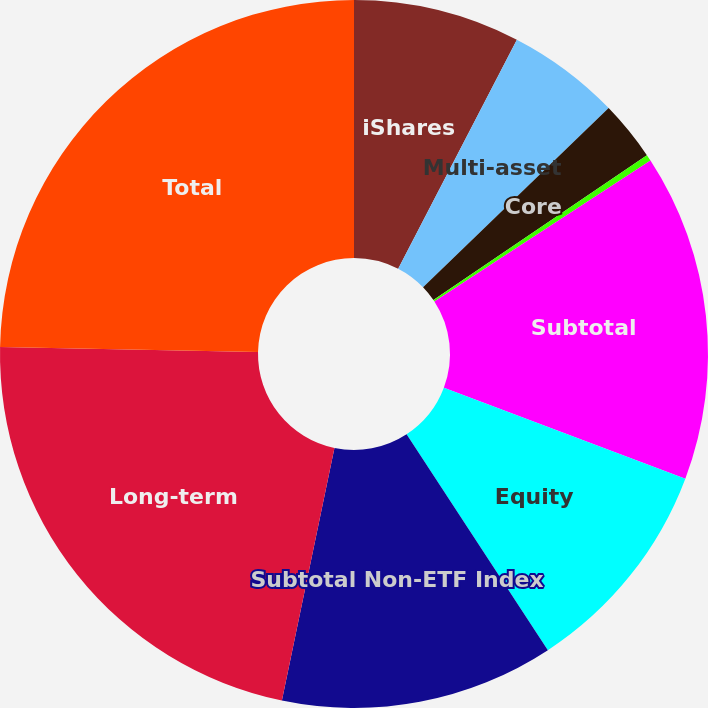Convert chart to OTSL. <chart><loc_0><loc_0><loc_500><loc_500><pie_chart><fcel>iShares<fcel>Multi-asset<fcel>Core<fcel>Currency and commodities (4)<fcel>Subtotal<fcel>Equity<fcel>Subtotal Non-ETF Index<fcel>Long-term<fcel>Total<nl><fcel>7.61%<fcel>5.17%<fcel>2.73%<fcel>0.29%<fcel>14.93%<fcel>10.05%<fcel>12.49%<fcel>22.05%<fcel>24.69%<nl></chart> 